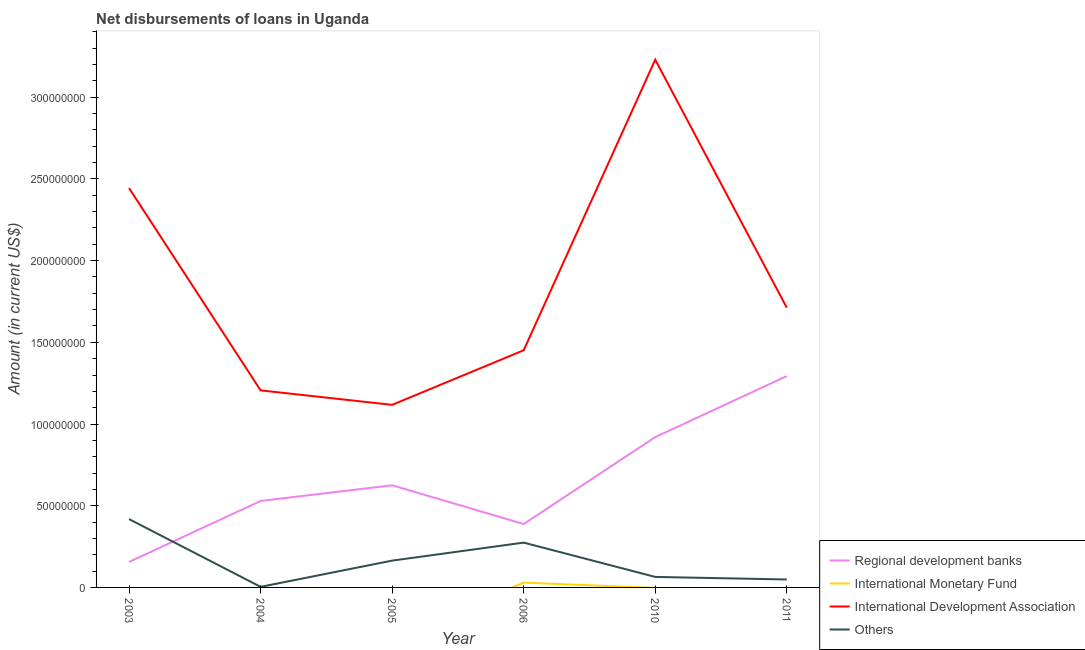Does the line corresponding to amount of loan disimbursed by international monetary fund intersect with the line corresponding to amount of loan disimbursed by international development association?
Your answer should be compact. No. What is the amount of loan disimbursed by other organisations in 2005?
Provide a short and direct response. 1.64e+07. Across all years, what is the maximum amount of loan disimbursed by regional development banks?
Your answer should be very brief. 1.29e+08. Across all years, what is the minimum amount of loan disimbursed by other organisations?
Offer a terse response. 3.56e+05. What is the total amount of loan disimbursed by international development association in the graph?
Your answer should be compact. 1.12e+09. What is the difference between the amount of loan disimbursed by other organisations in 2003 and that in 2005?
Offer a very short reply. 2.54e+07. What is the difference between the amount of loan disimbursed by international development association in 2006 and the amount of loan disimbursed by international monetary fund in 2005?
Provide a short and direct response. 1.45e+08. What is the average amount of loan disimbursed by international development association per year?
Ensure brevity in your answer.  1.86e+08. In the year 2004, what is the difference between the amount of loan disimbursed by other organisations and amount of loan disimbursed by international development association?
Offer a very short reply. -1.20e+08. What is the ratio of the amount of loan disimbursed by other organisations in 2004 to that in 2011?
Provide a short and direct response. 0.07. Is the difference between the amount of loan disimbursed by international development association in 2003 and 2011 greater than the difference between the amount of loan disimbursed by other organisations in 2003 and 2011?
Your response must be concise. Yes. What is the difference between the highest and the second highest amount of loan disimbursed by regional development banks?
Give a very brief answer. 3.74e+07. What is the difference between the highest and the lowest amount of loan disimbursed by international development association?
Ensure brevity in your answer.  2.11e+08. Is it the case that in every year, the sum of the amount of loan disimbursed by regional development banks and amount of loan disimbursed by international monetary fund is greater than the amount of loan disimbursed by international development association?
Your answer should be compact. No. Is the amount of loan disimbursed by regional development banks strictly less than the amount of loan disimbursed by other organisations over the years?
Offer a terse response. No. How many lines are there?
Your answer should be very brief. 4. Are the values on the major ticks of Y-axis written in scientific E-notation?
Your answer should be very brief. No. Does the graph contain any zero values?
Ensure brevity in your answer.  Yes. Does the graph contain grids?
Your answer should be very brief. No. How are the legend labels stacked?
Make the answer very short. Vertical. What is the title of the graph?
Provide a succinct answer. Net disbursements of loans in Uganda. Does "Negligence towards children" appear as one of the legend labels in the graph?
Ensure brevity in your answer.  No. What is the Amount (in current US$) in Regional development banks in 2003?
Your answer should be very brief. 1.56e+07. What is the Amount (in current US$) of International Monetary Fund in 2003?
Provide a succinct answer. 0. What is the Amount (in current US$) of International Development Association in 2003?
Offer a very short reply. 2.44e+08. What is the Amount (in current US$) of Others in 2003?
Ensure brevity in your answer.  4.18e+07. What is the Amount (in current US$) in Regional development banks in 2004?
Give a very brief answer. 5.29e+07. What is the Amount (in current US$) of International Monetary Fund in 2004?
Provide a short and direct response. 0. What is the Amount (in current US$) of International Development Association in 2004?
Keep it short and to the point. 1.21e+08. What is the Amount (in current US$) in Others in 2004?
Provide a short and direct response. 3.56e+05. What is the Amount (in current US$) in Regional development banks in 2005?
Offer a terse response. 6.25e+07. What is the Amount (in current US$) in International Development Association in 2005?
Keep it short and to the point. 1.12e+08. What is the Amount (in current US$) of Others in 2005?
Offer a terse response. 1.64e+07. What is the Amount (in current US$) in Regional development banks in 2006?
Ensure brevity in your answer.  3.88e+07. What is the Amount (in current US$) in International Monetary Fund in 2006?
Make the answer very short. 2.94e+06. What is the Amount (in current US$) in International Development Association in 2006?
Provide a short and direct response. 1.45e+08. What is the Amount (in current US$) in Others in 2006?
Offer a terse response. 2.74e+07. What is the Amount (in current US$) in Regional development banks in 2010?
Your answer should be compact. 9.20e+07. What is the Amount (in current US$) in International Development Association in 2010?
Your answer should be compact. 3.23e+08. What is the Amount (in current US$) of Others in 2010?
Keep it short and to the point. 6.43e+06. What is the Amount (in current US$) of Regional development banks in 2011?
Make the answer very short. 1.29e+08. What is the Amount (in current US$) in International Monetary Fund in 2011?
Offer a terse response. 0. What is the Amount (in current US$) of International Development Association in 2011?
Keep it short and to the point. 1.71e+08. What is the Amount (in current US$) in Others in 2011?
Your answer should be compact. 4.86e+06. Across all years, what is the maximum Amount (in current US$) of Regional development banks?
Ensure brevity in your answer.  1.29e+08. Across all years, what is the maximum Amount (in current US$) in International Monetary Fund?
Your response must be concise. 2.94e+06. Across all years, what is the maximum Amount (in current US$) of International Development Association?
Provide a succinct answer. 3.23e+08. Across all years, what is the maximum Amount (in current US$) in Others?
Your answer should be compact. 4.18e+07. Across all years, what is the minimum Amount (in current US$) of Regional development banks?
Ensure brevity in your answer.  1.56e+07. Across all years, what is the minimum Amount (in current US$) in International Development Association?
Keep it short and to the point. 1.12e+08. Across all years, what is the minimum Amount (in current US$) of Others?
Provide a short and direct response. 3.56e+05. What is the total Amount (in current US$) in Regional development banks in the graph?
Keep it short and to the point. 3.91e+08. What is the total Amount (in current US$) in International Monetary Fund in the graph?
Your answer should be very brief. 2.94e+06. What is the total Amount (in current US$) of International Development Association in the graph?
Offer a very short reply. 1.12e+09. What is the total Amount (in current US$) in Others in the graph?
Give a very brief answer. 9.73e+07. What is the difference between the Amount (in current US$) of Regional development banks in 2003 and that in 2004?
Provide a succinct answer. -3.73e+07. What is the difference between the Amount (in current US$) in International Development Association in 2003 and that in 2004?
Make the answer very short. 1.24e+08. What is the difference between the Amount (in current US$) of Others in 2003 and that in 2004?
Provide a short and direct response. 4.15e+07. What is the difference between the Amount (in current US$) in Regional development banks in 2003 and that in 2005?
Your answer should be very brief. -4.69e+07. What is the difference between the Amount (in current US$) in International Development Association in 2003 and that in 2005?
Give a very brief answer. 1.33e+08. What is the difference between the Amount (in current US$) of Others in 2003 and that in 2005?
Your answer should be very brief. 2.54e+07. What is the difference between the Amount (in current US$) in Regional development banks in 2003 and that in 2006?
Keep it short and to the point. -2.32e+07. What is the difference between the Amount (in current US$) in International Development Association in 2003 and that in 2006?
Keep it short and to the point. 9.93e+07. What is the difference between the Amount (in current US$) in Others in 2003 and that in 2006?
Offer a very short reply. 1.44e+07. What is the difference between the Amount (in current US$) of Regional development banks in 2003 and that in 2010?
Make the answer very short. -7.64e+07. What is the difference between the Amount (in current US$) of International Development Association in 2003 and that in 2010?
Offer a terse response. -7.86e+07. What is the difference between the Amount (in current US$) of Others in 2003 and that in 2010?
Give a very brief answer. 3.54e+07. What is the difference between the Amount (in current US$) of Regional development banks in 2003 and that in 2011?
Your answer should be very brief. -1.14e+08. What is the difference between the Amount (in current US$) in International Development Association in 2003 and that in 2011?
Your response must be concise. 7.32e+07. What is the difference between the Amount (in current US$) in Others in 2003 and that in 2011?
Your answer should be very brief. 3.70e+07. What is the difference between the Amount (in current US$) of Regional development banks in 2004 and that in 2005?
Your response must be concise. -9.59e+06. What is the difference between the Amount (in current US$) in International Development Association in 2004 and that in 2005?
Your response must be concise. 8.86e+06. What is the difference between the Amount (in current US$) in Others in 2004 and that in 2005?
Make the answer very short. -1.60e+07. What is the difference between the Amount (in current US$) in Regional development banks in 2004 and that in 2006?
Make the answer very short. 1.41e+07. What is the difference between the Amount (in current US$) of International Development Association in 2004 and that in 2006?
Offer a terse response. -2.45e+07. What is the difference between the Amount (in current US$) of Others in 2004 and that in 2006?
Provide a short and direct response. -2.71e+07. What is the difference between the Amount (in current US$) of Regional development banks in 2004 and that in 2010?
Provide a short and direct response. -3.91e+07. What is the difference between the Amount (in current US$) of International Development Association in 2004 and that in 2010?
Keep it short and to the point. -2.02e+08. What is the difference between the Amount (in current US$) of Others in 2004 and that in 2010?
Offer a very short reply. -6.08e+06. What is the difference between the Amount (in current US$) in Regional development banks in 2004 and that in 2011?
Ensure brevity in your answer.  -7.64e+07. What is the difference between the Amount (in current US$) in International Development Association in 2004 and that in 2011?
Ensure brevity in your answer.  -5.06e+07. What is the difference between the Amount (in current US$) of Others in 2004 and that in 2011?
Offer a terse response. -4.50e+06. What is the difference between the Amount (in current US$) of Regional development banks in 2005 and that in 2006?
Give a very brief answer. 2.37e+07. What is the difference between the Amount (in current US$) in International Development Association in 2005 and that in 2006?
Keep it short and to the point. -3.34e+07. What is the difference between the Amount (in current US$) in Others in 2005 and that in 2006?
Offer a terse response. -1.10e+07. What is the difference between the Amount (in current US$) in Regional development banks in 2005 and that in 2010?
Give a very brief answer. -2.95e+07. What is the difference between the Amount (in current US$) in International Development Association in 2005 and that in 2010?
Offer a very short reply. -2.11e+08. What is the difference between the Amount (in current US$) in Others in 2005 and that in 2010?
Offer a very short reply. 9.97e+06. What is the difference between the Amount (in current US$) in Regional development banks in 2005 and that in 2011?
Your response must be concise. -6.68e+07. What is the difference between the Amount (in current US$) in International Development Association in 2005 and that in 2011?
Provide a succinct answer. -5.94e+07. What is the difference between the Amount (in current US$) in Others in 2005 and that in 2011?
Make the answer very short. 1.15e+07. What is the difference between the Amount (in current US$) in Regional development banks in 2006 and that in 2010?
Ensure brevity in your answer.  -5.32e+07. What is the difference between the Amount (in current US$) of International Development Association in 2006 and that in 2010?
Make the answer very short. -1.78e+08. What is the difference between the Amount (in current US$) of Others in 2006 and that in 2010?
Provide a short and direct response. 2.10e+07. What is the difference between the Amount (in current US$) in Regional development banks in 2006 and that in 2011?
Make the answer very short. -9.05e+07. What is the difference between the Amount (in current US$) of International Development Association in 2006 and that in 2011?
Ensure brevity in your answer.  -2.60e+07. What is the difference between the Amount (in current US$) in Others in 2006 and that in 2011?
Provide a short and direct response. 2.26e+07. What is the difference between the Amount (in current US$) in Regional development banks in 2010 and that in 2011?
Your answer should be compact. -3.74e+07. What is the difference between the Amount (in current US$) of International Development Association in 2010 and that in 2011?
Make the answer very short. 1.52e+08. What is the difference between the Amount (in current US$) of Others in 2010 and that in 2011?
Keep it short and to the point. 1.57e+06. What is the difference between the Amount (in current US$) in Regional development banks in 2003 and the Amount (in current US$) in International Development Association in 2004?
Give a very brief answer. -1.05e+08. What is the difference between the Amount (in current US$) in Regional development banks in 2003 and the Amount (in current US$) in Others in 2004?
Provide a succinct answer. 1.52e+07. What is the difference between the Amount (in current US$) of International Development Association in 2003 and the Amount (in current US$) of Others in 2004?
Give a very brief answer. 2.44e+08. What is the difference between the Amount (in current US$) in Regional development banks in 2003 and the Amount (in current US$) in International Development Association in 2005?
Provide a succinct answer. -9.62e+07. What is the difference between the Amount (in current US$) of Regional development banks in 2003 and the Amount (in current US$) of Others in 2005?
Ensure brevity in your answer.  -8.16e+05. What is the difference between the Amount (in current US$) of International Development Association in 2003 and the Amount (in current US$) of Others in 2005?
Offer a terse response. 2.28e+08. What is the difference between the Amount (in current US$) in Regional development banks in 2003 and the Amount (in current US$) in International Monetary Fund in 2006?
Your answer should be compact. 1.26e+07. What is the difference between the Amount (in current US$) of Regional development banks in 2003 and the Amount (in current US$) of International Development Association in 2006?
Keep it short and to the point. -1.30e+08. What is the difference between the Amount (in current US$) in Regional development banks in 2003 and the Amount (in current US$) in Others in 2006?
Offer a very short reply. -1.18e+07. What is the difference between the Amount (in current US$) in International Development Association in 2003 and the Amount (in current US$) in Others in 2006?
Offer a very short reply. 2.17e+08. What is the difference between the Amount (in current US$) of Regional development banks in 2003 and the Amount (in current US$) of International Development Association in 2010?
Offer a terse response. -3.07e+08. What is the difference between the Amount (in current US$) in Regional development banks in 2003 and the Amount (in current US$) in Others in 2010?
Provide a succinct answer. 9.16e+06. What is the difference between the Amount (in current US$) in International Development Association in 2003 and the Amount (in current US$) in Others in 2010?
Your answer should be very brief. 2.38e+08. What is the difference between the Amount (in current US$) in Regional development banks in 2003 and the Amount (in current US$) in International Development Association in 2011?
Provide a succinct answer. -1.56e+08. What is the difference between the Amount (in current US$) in Regional development banks in 2003 and the Amount (in current US$) in Others in 2011?
Make the answer very short. 1.07e+07. What is the difference between the Amount (in current US$) in International Development Association in 2003 and the Amount (in current US$) in Others in 2011?
Provide a short and direct response. 2.40e+08. What is the difference between the Amount (in current US$) of Regional development banks in 2004 and the Amount (in current US$) of International Development Association in 2005?
Ensure brevity in your answer.  -5.88e+07. What is the difference between the Amount (in current US$) of Regional development banks in 2004 and the Amount (in current US$) of Others in 2005?
Keep it short and to the point. 3.65e+07. What is the difference between the Amount (in current US$) of International Development Association in 2004 and the Amount (in current US$) of Others in 2005?
Give a very brief answer. 1.04e+08. What is the difference between the Amount (in current US$) of Regional development banks in 2004 and the Amount (in current US$) of International Monetary Fund in 2006?
Your answer should be very brief. 5.00e+07. What is the difference between the Amount (in current US$) of Regional development banks in 2004 and the Amount (in current US$) of International Development Association in 2006?
Offer a terse response. -9.22e+07. What is the difference between the Amount (in current US$) in Regional development banks in 2004 and the Amount (in current US$) in Others in 2006?
Give a very brief answer. 2.55e+07. What is the difference between the Amount (in current US$) of International Development Association in 2004 and the Amount (in current US$) of Others in 2006?
Your answer should be compact. 9.32e+07. What is the difference between the Amount (in current US$) of Regional development banks in 2004 and the Amount (in current US$) of International Development Association in 2010?
Your answer should be compact. -2.70e+08. What is the difference between the Amount (in current US$) of Regional development banks in 2004 and the Amount (in current US$) of Others in 2010?
Offer a very short reply. 4.65e+07. What is the difference between the Amount (in current US$) in International Development Association in 2004 and the Amount (in current US$) in Others in 2010?
Offer a terse response. 1.14e+08. What is the difference between the Amount (in current US$) in Regional development banks in 2004 and the Amount (in current US$) in International Development Association in 2011?
Give a very brief answer. -1.18e+08. What is the difference between the Amount (in current US$) of Regional development banks in 2004 and the Amount (in current US$) of Others in 2011?
Ensure brevity in your answer.  4.81e+07. What is the difference between the Amount (in current US$) of International Development Association in 2004 and the Amount (in current US$) of Others in 2011?
Offer a very short reply. 1.16e+08. What is the difference between the Amount (in current US$) of Regional development banks in 2005 and the Amount (in current US$) of International Monetary Fund in 2006?
Your answer should be compact. 5.96e+07. What is the difference between the Amount (in current US$) in Regional development banks in 2005 and the Amount (in current US$) in International Development Association in 2006?
Keep it short and to the point. -8.26e+07. What is the difference between the Amount (in current US$) in Regional development banks in 2005 and the Amount (in current US$) in Others in 2006?
Make the answer very short. 3.51e+07. What is the difference between the Amount (in current US$) in International Development Association in 2005 and the Amount (in current US$) in Others in 2006?
Offer a very short reply. 8.43e+07. What is the difference between the Amount (in current US$) of Regional development banks in 2005 and the Amount (in current US$) of International Development Association in 2010?
Make the answer very short. -2.60e+08. What is the difference between the Amount (in current US$) of Regional development banks in 2005 and the Amount (in current US$) of Others in 2010?
Give a very brief answer. 5.61e+07. What is the difference between the Amount (in current US$) of International Development Association in 2005 and the Amount (in current US$) of Others in 2010?
Your response must be concise. 1.05e+08. What is the difference between the Amount (in current US$) in Regional development banks in 2005 and the Amount (in current US$) in International Development Association in 2011?
Ensure brevity in your answer.  -1.09e+08. What is the difference between the Amount (in current US$) in Regional development banks in 2005 and the Amount (in current US$) in Others in 2011?
Give a very brief answer. 5.76e+07. What is the difference between the Amount (in current US$) in International Development Association in 2005 and the Amount (in current US$) in Others in 2011?
Give a very brief answer. 1.07e+08. What is the difference between the Amount (in current US$) of Regional development banks in 2006 and the Amount (in current US$) of International Development Association in 2010?
Your answer should be compact. -2.84e+08. What is the difference between the Amount (in current US$) of Regional development banks in 2006 and the Amount (in current US$) of Others in 2010?
Your response must be concise. 3.24e+07. What is the difference between the Amount (in current US$) in International Monetary Fund in 2006 and the Amount (in current US$) in International Development Association in 2010?
Offer a very short reply. -3.20e+08. What is the difference between the Amount (in current US$) of International Monetary Fund in 2006 and the Amount (in current US$) of Others in 2010?
Your response must be concise. -3.49e+06. What is the difference between the Amount (in current US$) of International Development Association in 2006 and the Amount (in current US$) of Others in 2010?
Offer a very short reply. 1.39e+08. What is the difference between the Amount (in current US$) in Regional development banks in 2006 and the Amount (in current US$) in International Development Association in 2011?
Your answer should be compact. -1.32e+08. What is the difference between the Amount (in current US$) in Regional development banks in 2006 and the Amount (in current US$) in Others in 2011?
Offer a very short reply. 3.39e+07. What is the difference between the Amount (in current US$) of International Monetary Fund in 2006 and the Amount (in current US$) of International Development Association in 2011?
Your response must be concise. -1.68e+08. What is the difference between the Amount (in current US$) in International Monetary Fund in 2006 and the Amount (in current US$) in Others in 2011?
Your answer should be compact. -1.92e+06. What is the difference between the Amount (in current US$) of International Development Association in 2006 and the Amount (in current US$) of Others in 2011?
Provide a short and direct response. 1.40e+08. What is the difference between the Amount (in current US$) in Regional development banks in 2010 and the Amount (in current US$) in International Development Association in 2011?
Ensure brevity in your answer.  -7.92e+07. What is the difference between the Amount (in current US$) in Regional development banks in 2010 and the Amount (in current US$) in Others in 2011?
Provide a succinct answer. 8.71e+07. What is the difference between the Amount (in current US$) of International Development Association in 2010 and the Amount (in current US$) of Others in 2011?
Offer a very short reply. 3.18e+08. What is the average Amount (in current US$) in Regional development banks per year?
Your answer should be very brief. 6.52e+07. What is the average Amount (in current US$) of International Monetary Fund per year?
Your answer should be very brief. 4.90e+05. What is the average Amount (in current US$) in International Development Association per year?
Offer a terse response. 1.86e+08. What is the average Amount (in current US$) of Others per year?
Give a very brief answer. 1.62e+07. In the year 2003, what is the difference between the Amount (in current US$) of Regional development banks and Amount (in current US$) of International Development Association?
Provide a short and direct response. -2.29e+08. In the year 2003, what is the difference between the Amount (in current US$) of Regional development banks and Amount (in current US$) of Others?
Provide a short and direct response. -2.62e+07. In the year 2003, what is the difference between the Amount (in current US$) in International Development Association and Amount (in current US$) in Others?
Keep it short and to the point. 2.03e+08. In the year 2004, what is the difference between the Amount (in current US$) in Regional development banks and Amount (in current US$) in International Development Association?
Ensure brevity in your answer.  -6.77e+07. In the year 2004, what is the difference between the Amount (in current US$) in Regional development banks and Amount (in current US$) in Others?
Provide a succinct answer. 5.26e+07. In the year 2004, what is the difference between the Amount (in current US$) in International Development Association and Amount (in current US$) in Others?
Provide a short and direct response. 1.20e+08. In the year 2005, what is the difference between the Amount (in current US$) of Regional development banks and Amount (in current US$) of International Development Association?
Ensure brevity in your answer.  -4.92e+07. In the year 2005, what is the difference between the Amount (in current US$) in Regional development banks and Amount (in current US$) in Others?
Keep it short and to the point. 4.61e+07. In the year 2005, what is the difference between the Amount (in current US$) of International Development Association and Amount (in current US$) of Others?
Ensure brevity in your answer.  9.53e+07. In the year 2006, what is the difference between the Amount (in current US$) in Regional development banks and Amount (in current US$) in International Monetary Fund?
Your answer should be compact. 3.59e+07. In the year 2006, what is the difference between the Amount (in current US$) of Regional development banks and Amount (in current US$) of International Development Association?
Give a very brief answer. -1.06e+08. In the year 2006, what is the difference between the Amount (in current US$) of Regional development banks and Amount (in current US$) of Others?
Make the answer very short. 1.14e+07. In the year 2006, what is the difference between the Amount (in current US$) of International Monetary Fund and Amount (in current US$) of International Development Association?
Offer a terse response. -1.42e+08. In the year 2006, what is the difference between the Amount (in current US$) in International Monetary Fund and Amount (in current US$) in Others?
Give a very brief answer. -2.45e+07. In the year 2006, what is the difference between the Amount (in current US$) of International Development Association and Amount (in current US$) of Others?
Make the answer very short. 1.18e+08. In the year 2010, what is the difference between the Amount (in current US$) of Regional development banks and Amount (in current US$) of International Development Association?
Make the answer very short. -2.31e+08. In the year 2010, what is the difference between the Amount (in current US$) in Regional development banks and Amount (in current US$) in Others?
Provide a succinct answer. 8.56e+07. In the year 2010, what is the difference between the Amount (in current US$) of International Development Association and Amount (in current US$) of Others?
Give a very brief answer. 3.17e+08. In the year 2011, what is the difference between the Amount (in current US$) of Regional development banks and Amount (in current US$) of International Development Association?
Keep it short and to the point. -4.18e+07. In the year 2011, what is the difference between the Amount (in current US$) of Regional development banks and Amount (in current US$) of Others?
Keep it short and to the point. 1.24e+08. In the year 2011, what is the difference between the Amount (in current US$) of International Development Association and Amount (in current US$) of Others?
Your response must be concise. 1.66e+08. What is the ratio of the Amount (in current US$) of Regional development banks in 2003 to that in 2004?
Ensure brevity in your answer.  0.29. What is the ratio of the Amount (in current US$) of International Development Association in 2003 to that in 2004?
Provide a succinct answer. 2.03. What is the ratio of the Amount (in current US$) of Others in 2003 to that in 2004?
Make the answer very short. 117.46. What is the ratio of the Amount (in current US$) in Regional development banks in 2003 to that in 2005?
Your answer should be compact. 0.25. What is the ratio of the Amount (in current US$) of International Development Association in 2003 to that in 2005?
Keep it short and to the point. 2.19. What is the ratio of the Amount (in current US$) of Others in 2003 to that in 2005?
Offer a terse response. 2.55. What is the ratio of the Amount (in current US$) of Regional development banks in 2003 to that in 2006?
Provide a succinct answer. 0.4. What is the ratio of the Amount (in current US$) of International Development Association in 2003 to that in 2006?
Ensure brevity in your answer.  1.68. What is the ratio of the Amount (in current US$) of Others in 2003 to that in 2006?
Give a very brief answer. 1.52. What is the ratio of the Amount (in current US$) of Regional development banks in 2003 to that in 2010?
Offer a very short reply. 0.17. What is the ratio of the Amount (in current US$) of International Development Association in 2003 to that in 2010?
Your answer should be compact. 0.76. What is the ratio of the Amount (in current US$) in Others in 2003 to that in 2010?
Your answer should be compact. 6.5. What is the ratio of the Amount (in current US$) of Regional development banks in 2003 to that in 2011?
Your answer should be very brief. 0.12. What is the ratio of the Amount (in current US$) in International Development Association in 2003 to that in 2011?
Make the answer very short. 1.43. What is the ratio of the Amount (in current US$) of Others in 2003 to that in 2011?
Offer a very short reply. 8.61. What is the ratio of the Amount (in current US$) in Regional development banks in 2004 to that in 2005?
Offer a very short reply. 0.85. What is the ratio of the Amount (in current US$) of International Development Association in 2004 to that in 2005?
Make the answer very short. 1.08. What is the ratio of the Amount (in current US$) of Others in 2004 to that in 2005?
Provide a short and direct response. 0.02. What is the ratio of the Amount (in current US$) in Regional development banks in 2004 to that in 2006?
Offer a very short reply. 1.36. What is the ratio of the Amount (in current US$) in International Development Association in 2004 to that in 2006?
Provide a succinct answer. 0.83. What is the ratio of the Amount (in current US$) of Others in 2004 to that in 2006?
Ensure brevity in your answer.  0.01. What is the ratio of the Amount (in current US$) in Regional development banks in 2004 to that in 2010?
Offer a very short reply. 0.58. What is the ratio of the Amount (in current US$) of International Development Association in 2004 to that in 2010?
Offer a terse response. 0.37. What is the ratio of the Amount (in current US$) of Others in 2004 to that in 2010?
Make the answer very short. 0.06. What is the ratio of the Amount (in current US$) of Regional development banks in 2004 to that in 2011?
Ensure brevity in your answer.  0.41. What is the ratio of the Amount (in current US$) in International Development Association in 2004 to that in 2011?
Provide a short and direct response. 0.7. What is the ratio of the Amount (in current US$) of Others in 2004 to that in 2011?
Provide a short and direct response. 0.07. What is the ratio of the Amount (in current US$) of Regional development banks in 2005 to that in 2006?
Offer a terse response. 1.61. What is the ratio of the Amount (in current US$) in International Development Association in 2005 to that in 2006?
Ensure brevity in your answer.  0.77. What is the ratio of the Amount (in current US$) in Others in 2005 to that in 2006?
Ensure brevity in your answer.  0.6. What is the ratio of the Amount (in current US$) of Regional development banks in 2005 to that in 2010?
Give a very brief answer. 0.68. What is the ratio of the Amount (in current US$) in International Development Association in 2005 to that in 2010?
Your answer should be very brief. 0.35. What is the ratio of the Amount (in current US$) in Others in 2005 to that in 2010?
Ensure brevity in your answer.  2.55. What is the ratio of the Amount (in current US$) in Regional development banks in 2005 to that in 2011?
Provide a short and direct response. 0.48. What is the ratio of the Amount (in current US$) in International Development Association in 2005 to that in 2011?
Provide a succinct answer. 0.65. What is the ratio of the Amount (in current US$) in Others in 2005 to that in 2011?
Your answer should be very brief. 3.38. What is the ratio of the Amount (in current US$) in Regional development banks in 2006 to that in 2010?
Provide a succinct answer. 0.42. What is the ratio of the Amount (in current US$) in International Development Association in 2006 to that in 2010?
Your answer should be very brief. 0.45. What is the ratio of the Amount (in current US$) of Others in 2006 to that in 2010?
Provide a short and direct response. 4.26. What is the ratio of the Amount (in current US$) in International Development Association in 2006 to that in 2011?
Keep it short and to the point. 0.85. What is the ratio of the Amount (in current US$) in Others in 2006 to that in 2011?
Your answer should be very brief. 5.64. What is the ratio of the Amount (in current US$) of Regional development banks in 2010 to that in 2011?
Offer a very short reply. 0.71. What is the ratio of the Amount (in current US$) of International Development Association in 2010 to that in 2011?
Your answer should be compact. 1.89. What is the ratio of the Amount (in current US$) in Others in 2010 to that in 2011?
Your answer should be very brief. 1.32. What is the difference between the highest and the second highest Amount (in current US$) in Regional development banks?
Keep it short and to the point. 3.74e+07. What is the difference between the highest and the second highest Amount (in current US$) in International Development Association?
Your response must be concise. 7.86e+07. What is the difference between the highest and the second highest Amount (in current US$) in Others?
Keep it short and to the point. 1.44e+07. What is the difference between the highest and the lowest Amount (in current US$) of Regional development banks?
Your response must be concise. 1.14e+08. What is the difference between the highest and the lowest Amount (in current US$) in International Monetary Fund?
Your answer should be compact. 2.94e+06. What is the difference between the highest and the lowest Amount (in current US$) in International Development Association?
Offer a very short reply. 2.11e+08. What is the difference between the highest and the lowest Amount (in current US$) of Others?
Keep it short and to the point. 4.15e+07. 